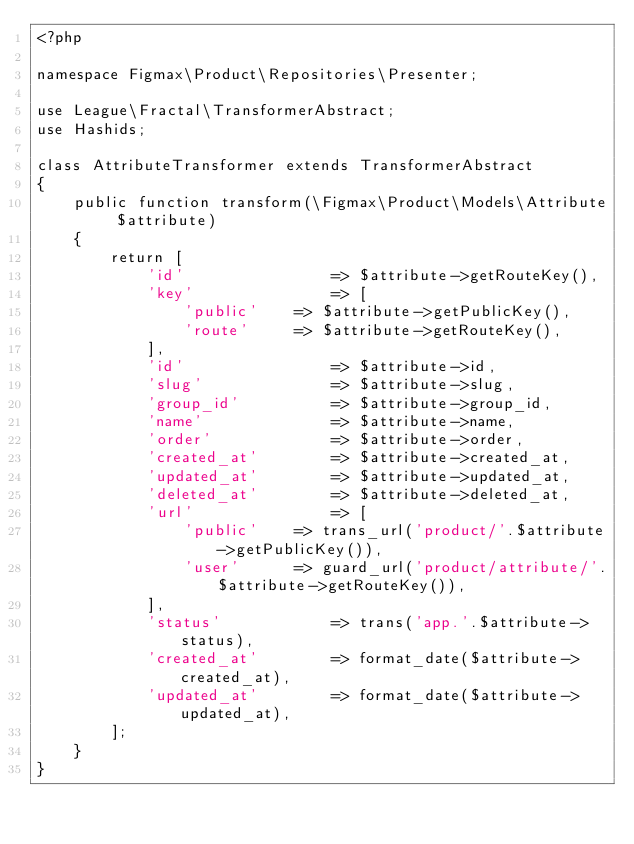<code> <loc_0><loc_0><loc_500><loc_500><_PHP_><?php

namespace Figmax\Product\Repositories\Presenter;

use League\Fractal\TransformerAbstract;
use Hashids;

class AttributeTransformer extends TransformerAbstract
{
    public function transform(\Figmax\Product\Models\Attribute $attribute)
    {
        return [
            'id'                => $attribute->getRouteKey(),
            'key'               => [
                'public'    => $attribute->getPublicKey(),
                'route'     => $attribute->getRouteKey(),
            ], 
            'id'                => $attribute->id,
            'slug'              => $attribute->slug,
            'group_id'          => $attribute->group_id,
            'name'              => $attribute->name,
            'order'             => $attribute->order,
            'created_at'        => $attribute->created_at,
            'updated_at'        => $attribute->updated_at,
            'deleted_at'        => $attribute->deleted_at,
            'url'               => [
                'public'    => trans_url('product/'.$attribute->getPublicKey()),
                'user'      => guard_url('product/attribute/'.$attribute->getRouteKey()),
            ], 
            'status'            => trans('app.'.$attribute->status),
            'created_at'        => format_date($attribute->created_at),
            'updated_at'        => format_date($attribute->updated_at),
        ];
    }
}</code> 